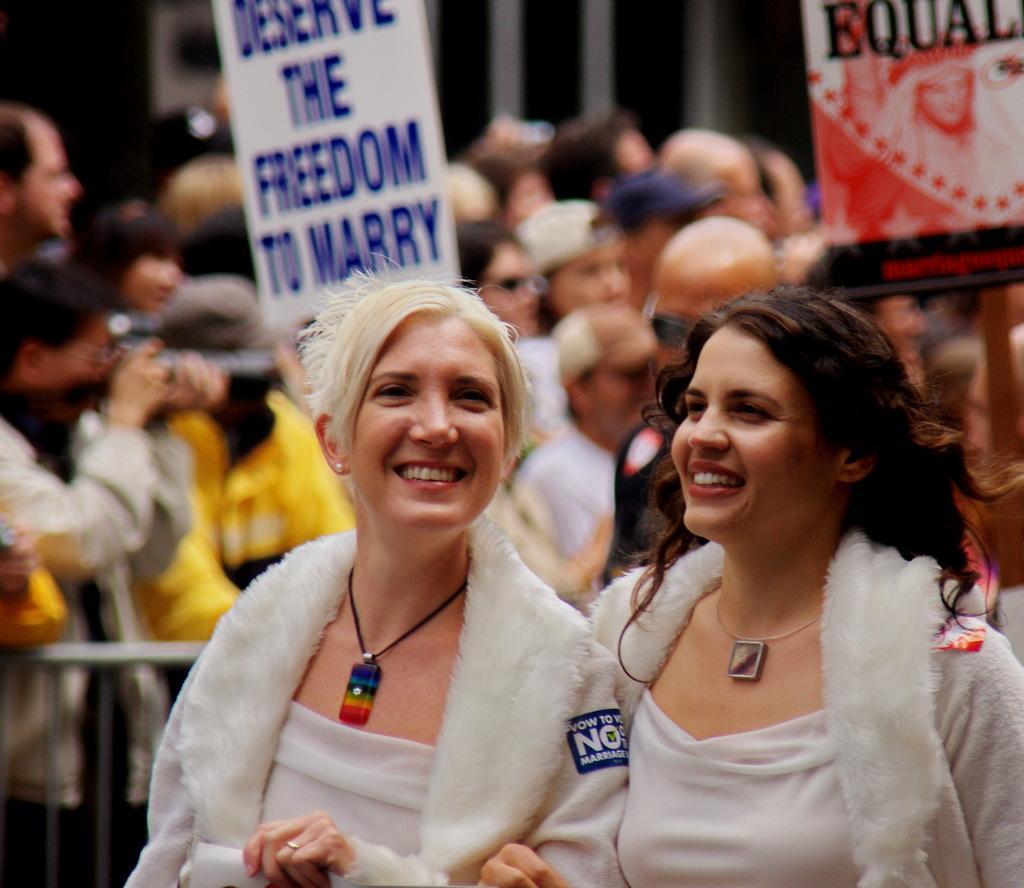Please provide a concise description of this image. There are two women standing and smiling. In the background, I can see a group of people standing. I think these are the banners. On the left side of the image, that looks like a barricade. This person is holding a camera in his hand. 